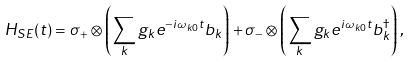<formula> <loc_0><loc_0><loc_500><loc_500>H _ { S E } ( t ) = \sigma _ { + } \otimes \left ( \sum _ { k } g _ { k } e ^ { - i \omega _ { k 0 } t } b _ { k } \right ) + \sigma _ { - } \otimes \left ( \sum _ { k } g _ { k } e ^ { i \omega _ { k 0 } t } b _ { k } ^ { \dagger } \right ) ,</formula> 